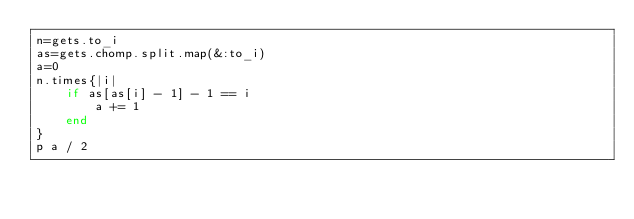<code> <loc_0><loc_0><loc_500><loc_500><_Ruby_>n=gets.to_i
as=gets.chomp.split.map(&:to_i)
a=0
n.times{|i|
    if as[as[i] - 1] - 1 == i
        a += 1
    end
}
p a / 2
</code> 